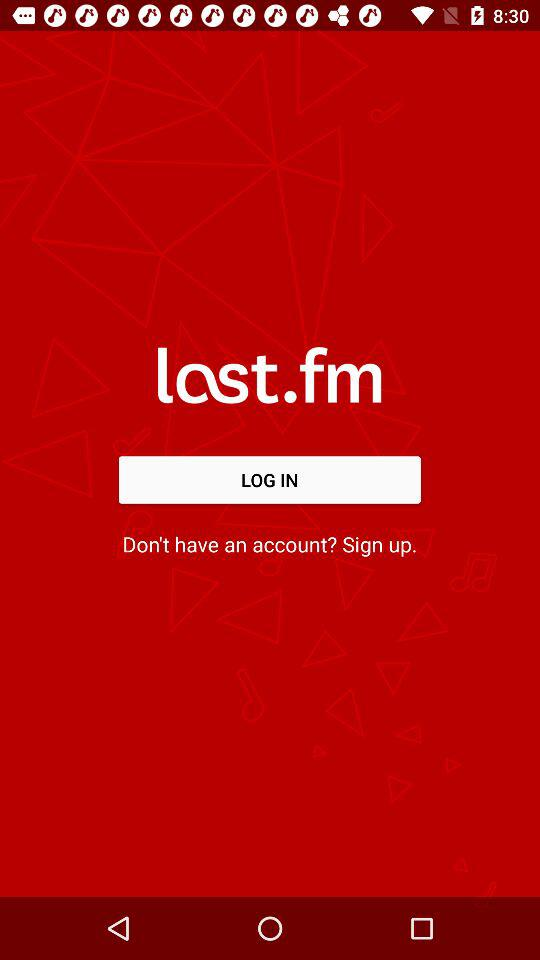What’s the app name? The app name is "last.fm". 